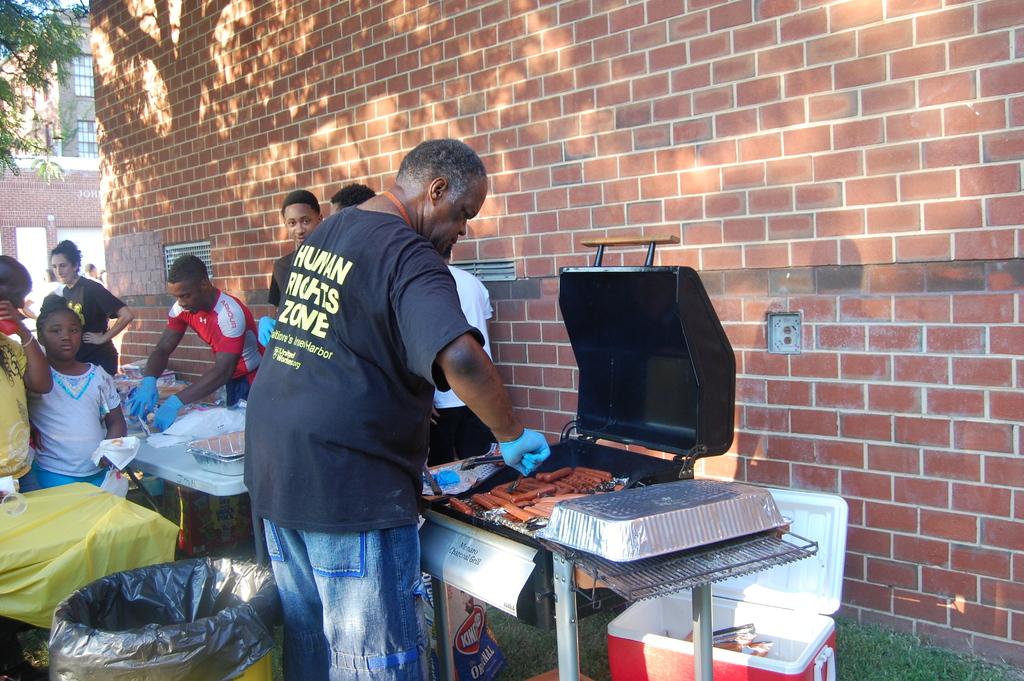Does his shirt say "human rights" on it?
Ensure brevity in your answer.  Yes. What is written on the grill?
Give a very brief answer. Charcoal grill. 